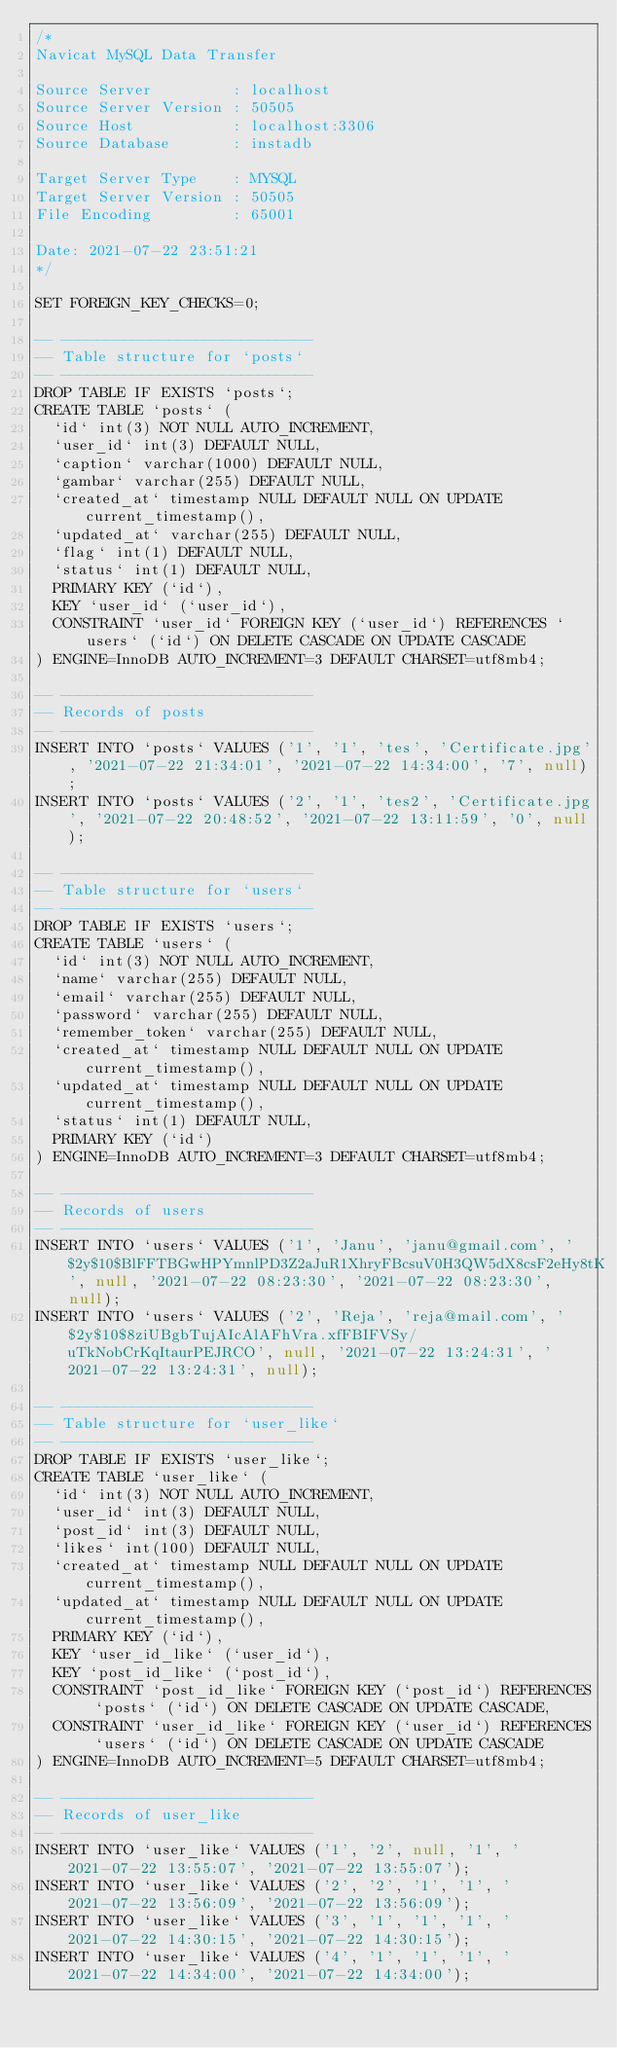Convert code to text. <code><loc_0><loc_0><loc_500><loc_500><_SQL_>/*
Navicat MySQL Data Transfer

Source Server         : localhost
Source Server Version : 50505
Source Host           : localhost:3306
Source Database       : instadb

Target Server Type    : MYSQL
Target Server Version : 50505
File Encoding         : 65001

Date: 2021-07-22 23:51:21
*/

SET FOREIGN_KEY_CHECKS=0;

-- ----------------------------
-- Table structure for `posts`
-- ----------------------------
DROP TABLE IF EXISTS `posts`;
CREATE TABLE `posts` (
  `id` int(3) NOT NULL AUTO_INCREMENT,
  `user_id` int(3) DEFAULT NULL,
  `caption` varchar(1000) DEFAULT NULL,
  `gambar` varchar(255) DEFAULT NULL,
  `created_at` timestamp NULL DEFAULT NULL ON UPDATE current_timestamp(),
  `updated_at` varchar(255) DEFAULT NULL,
  `flag` int(1) DEFAULT NULL,
  `status` int(1) DEFAULT NULL,
  PRIMARY KEY (`id`),
  KEY `user_id` (`user_id`),
  CONSTRAINT `user_id` FOREIGN KEY (`user_id`) REFERENCES `users` (`id`) ON DELETE CASCADE ON UPDATE CASCADE
) ENGINE=InnoDB AUTO_INCREMENT=3 DEFAULT CHARSET=utf8mb4;

-- ----------------------------
-- Records of posts
-- ----------------------------
INSERT INTO `posts` VALUES ('1', '1', 'tes', 'Certificate.jpg', '2021-07-22 21:34:01', '2021-07-22 14:34:00', '7', null);
INSERT INTO `posts` VALUES ('2', '1', 'tes2', 'Certificate.jpg', '2021-07-22 20:48:52', '2021-07-22 13:11:59', '0', null);

-- ----------------------------
-- Table structure for `users`
-- ----------------------------
DROP TABLE IF EXISTS `users`;
CREATE TABLE `users` (
  `id` int(3) NOT NULL AUTO_INCREMENT,
  `name` varchar(255) DEFAULT NULL,
  `email` varchar(255) DEFAULT NULL,
  `password` varchar(255) DEFAULT NULL,
  `remember_token` varchar(255) DEFAULT NULL,
  `created_at` timestamp NULL DEFAULT NULL ON UPDATE current_timestamp(),
  `updated_at` timestamp NULL DEFAULT NULL ON UPDATE current_timestamp(),
  `status` int(1) DEFAULT NULL,
  PRIMARY KEY (`id`)
) ENGINE=InnoDB AUTO_INCREMENT=3 DEFAULT CHARSET=utf8mb4;

-- ----------------------------
-- Records of users
-- ----------------------------
INSERT INTO `users` VALUES ('1', 'Janu', 'janu@gmail.com', '$2y$10$BlFFTBGwHPYmnlPD3Z2aJuR1XhryFBcsuV0H3QW5dX8csF2eHy8tK', null, '2021-07-22 08:23:30', '2021-07-22 08:23:30', null);
INSERT INTO `users` VALUES ('2', 'Reja', 'reja@mail.com', '$2y$10$8ziUBgbTujAIcAlAFhVra.xfFBIFVSy/uTkNobCrKqItaurPEJRCO', null, '2021-07-22 13:24:31', '2021-07-22 13:24:31', null);

-- ----------------------------
-- Table structure for `user_like`
-- ----------------------------
DROP TABLE IF EXISTS `user_like`;
CREATE TABLE `user_like` (
  `id` int(3) NOT NULL AUTO_INCREMENT,
  `user_id` int(3) DEFAULT NULL,
  `post_id` int(3) DEFAULT NULL,
  `likes` int(100) DEFAULT NULL,
  `created_at` timestamp NULL DEFAULT NULL ON UPDATE current_timestamp(),
  `updated_at` timestamp NULL DEFAULT NULL ON UPDATE current_timestamp(),
  PRIMARY KEY (`id`),
  KEY `user_id_like` (`user_id`),
  KEY `post_id_like` (`post_id`),
  CONSTRAINT `post_id_like` FOREIGN KEY (`post_id`) REFERENCES `posts` (`id`) ON DELETE CASCADE ON UPDATE CASCADE,
  CONSTRAINT `user_id_like` FOREIGN KEY (`user_id`) REFERENCES `users` (`id`) ON DELETE CASCADE ON UPDATE CASCADE
) ENGINE=InnoDB AUTO_INCREMENT=5 DEFAULT CHARSET=utf8mb4;

-- ----------------------------
-- Records of user_like
-- ----------------------------
INSERT INTO `user_like` VALUES ('1', '2', null, '1', '2021-07-22 13:55:07', '2021-07-22 13:55:07');
INSERT INTO `user_like` VALUES ('2', '2', '1', '1', '2021-07-22 13:56:09', '2021-07-22 13:56:09');
INSERT INTO `user_like` VALUES ('3', '1', '1', '1', '2021-07-22 14:30:15', '2021-07-22 14:30:15');
INSERT INTO `user_like` VALUES ('4', '1', '1', '1', '2021-07-22 14:34:00', '2021-07-22 14:34:00');
</code> 